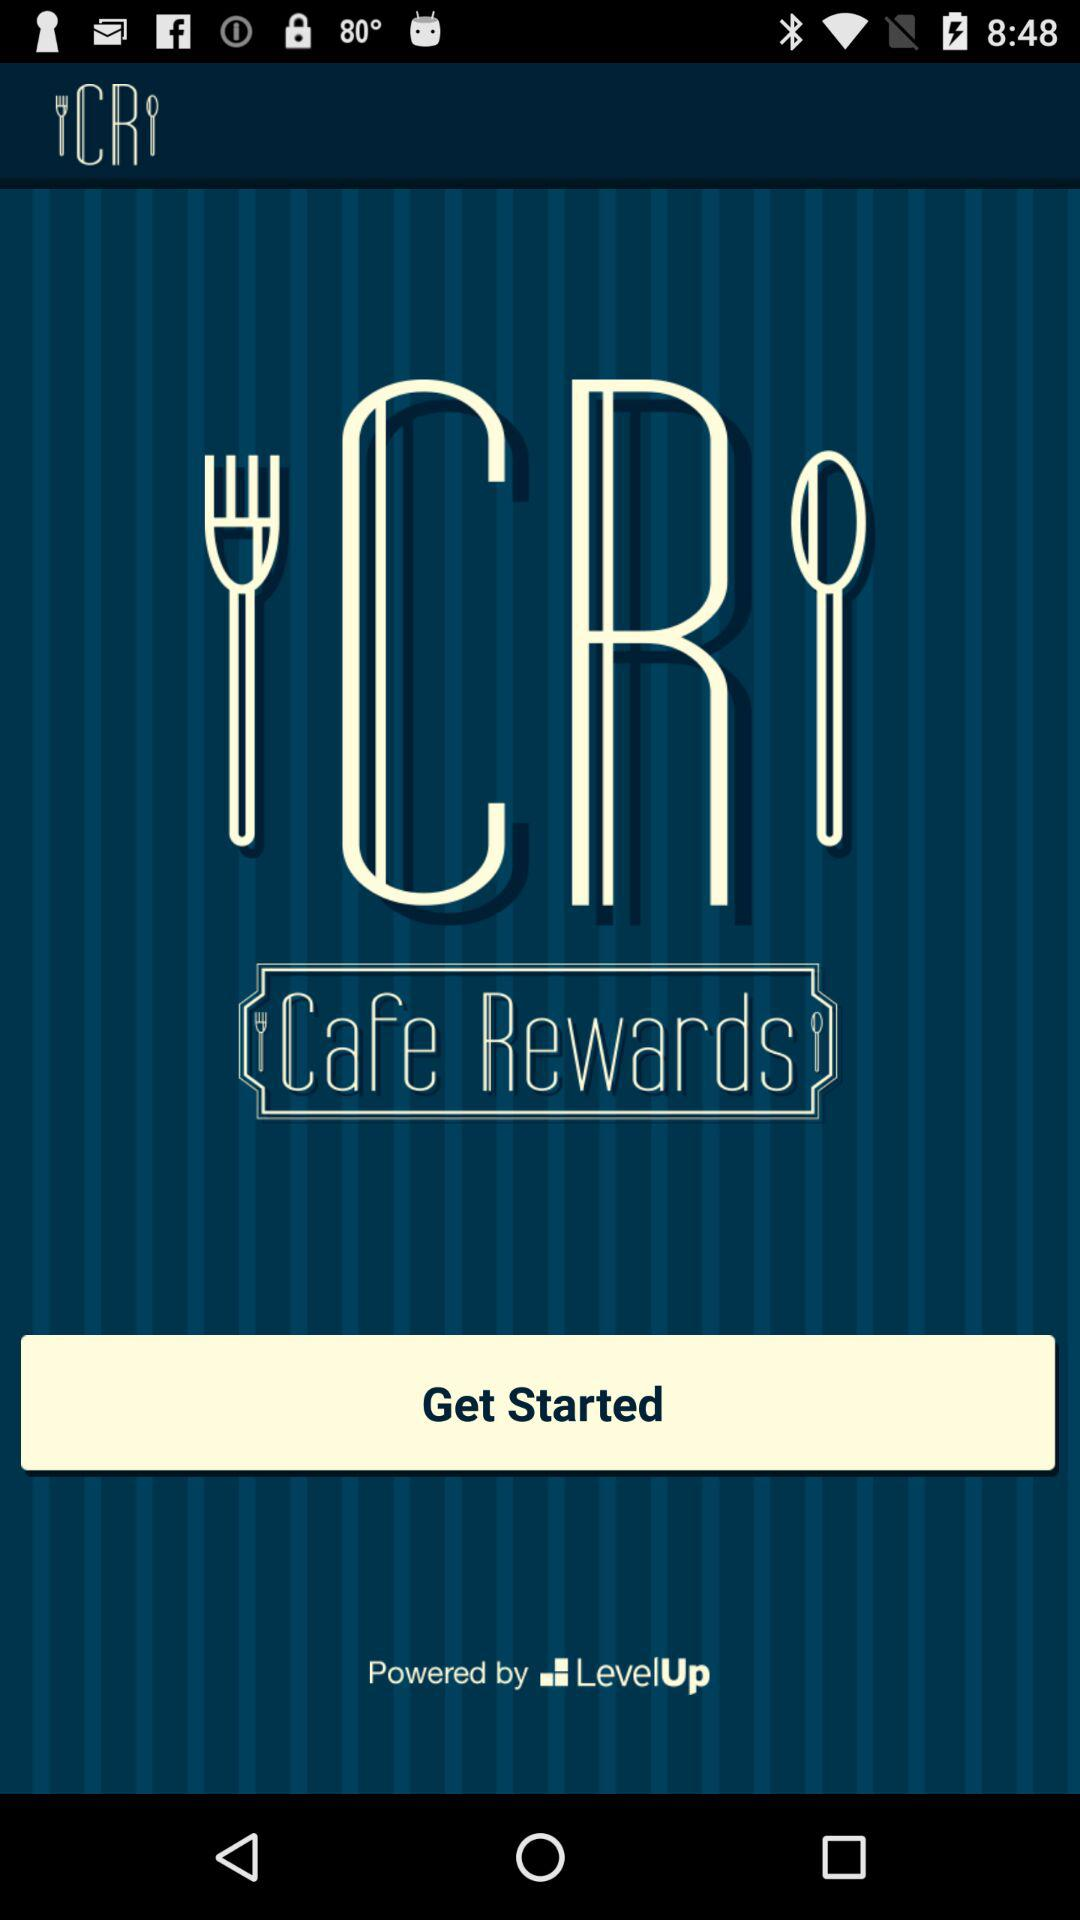What is the name of the application? The name of the application is "Cafe Rewards". 